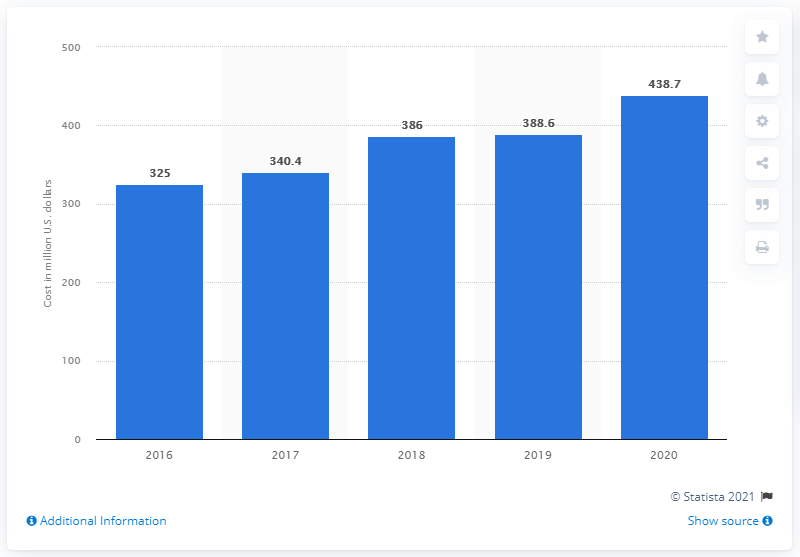Give some essential details in this illustration. In the previous year, Match Group spent 388.6 million dollars on advertising in the United States. Match Group spent approximately $438.7 million on advertising in 2019. 